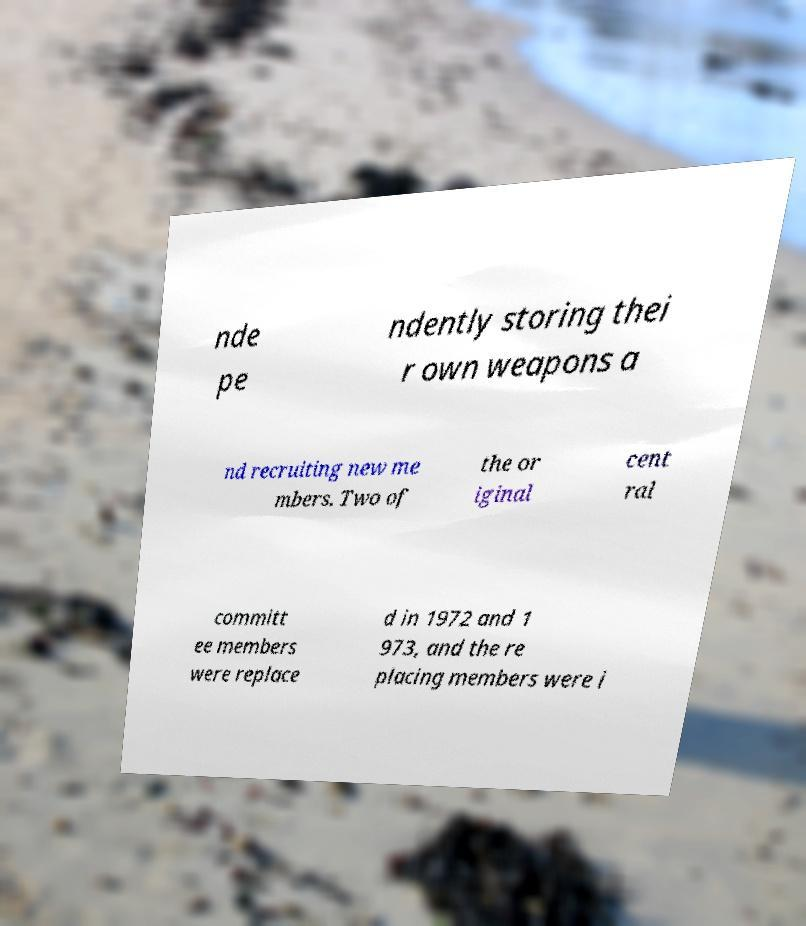What messages or text are displayed in this image? I need them in a readable, typed format. nde pe ndently storing thei r own weapons a nd recruiting new me mbers. Two of the or iginal cent ral committ ee members were replace d in 1972 and 1 973, and the re placing members were i 